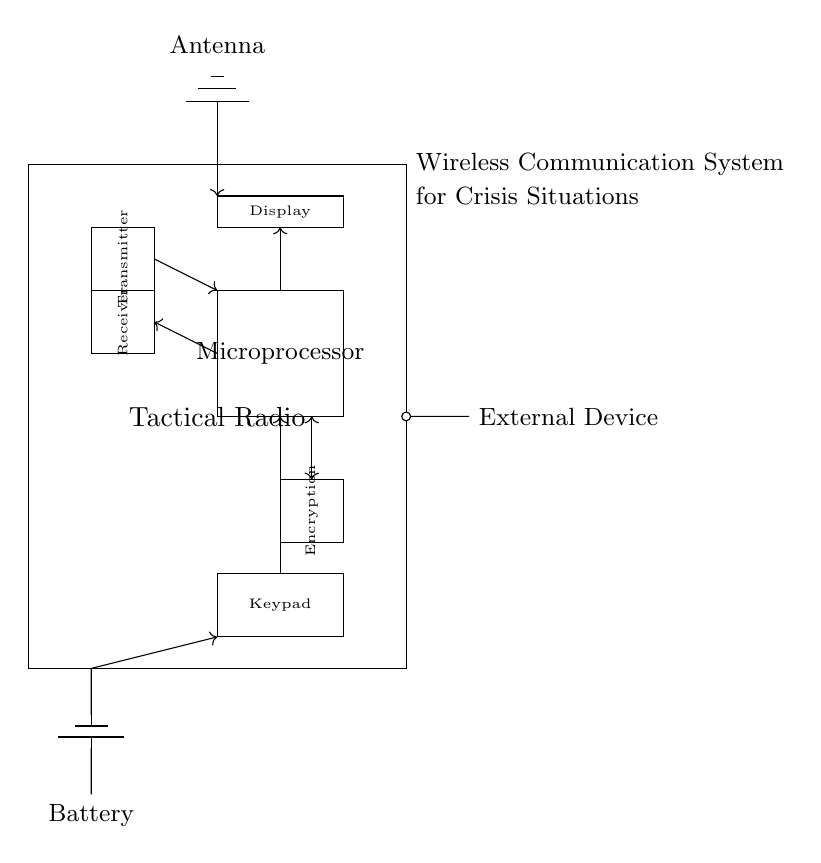What is the main component of the system? The main component, central to the function of the device, is the Tactical Radio, which contains essential parts like the transmitter and receiver for communication.
Answer: Tactical Radio What does the microprocessor do in this circuit? The microprocessor serves as the control unit, processing information and coordinating between the different parts, such as handling inputs from the keypad and managing outputs to the display and encryption module.
Answer: Control unit How many main sections are in the Tactical Radio? The Tactical Radio has five main sections: Transmitter, Receiver, Microprocessor, Encryption module, and Display.
Answer: Five What is the function of the antenna? The antenna is responsible for receiving and transmitting radio signals, enabling wireless communication with other devices, making it vital for tactical operations.
Answer: Wireless communication What is the purpose of the encryption module? The encryption module employs algorithms to secure data, ensuring that communication remains private and protected against unauthorized access, which is crucial in crisis situations.
Answer: Secure data Which component connects the Tactical Radio to external devices? The external device connection is facilitated through a short connection labeled as "External Device," indicating the interfacing capability for additional functionalities or data exchange.
Answer: External Device How is power supplied to the Tactical Radio? Power is supplied through the battery, which provides the necessary voltage to the Tactical Radio and its components, ensuring operational capability in the field.
Answer: Battery 